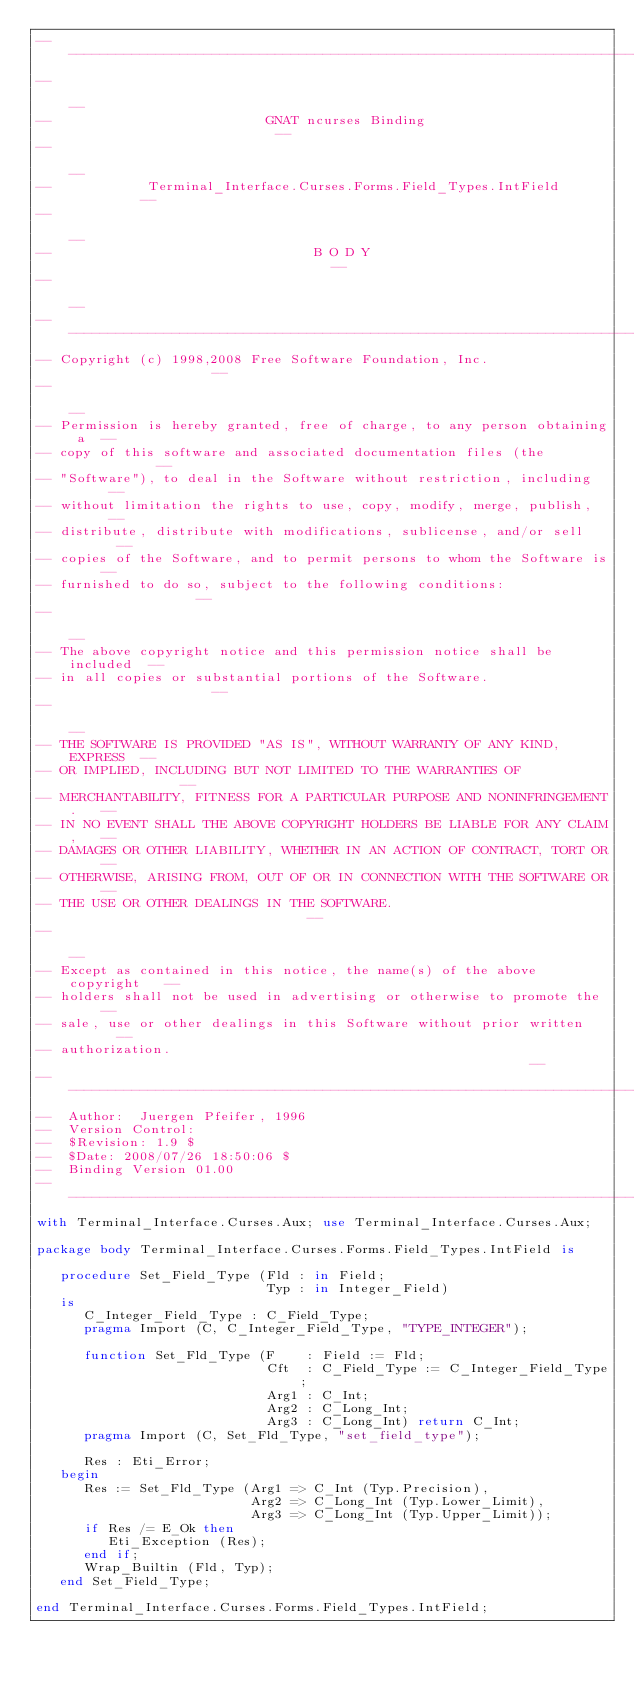<code> <loc_0><loc_0><loc_500><loc_500><_Ada_>------------------------------------------------------------------------------
--                                                                          --
--                           GNAT ncurses Binding                           --
--                                                                          --
--            Terminal_Interface.Curses.Forms.Field_Types.IntField          --
--                                                                          --
--                                 B O D Y                                  --
--                                                                          --
------------------------------------------------------------------------------
-- Copyright (c) 1998,2008 Free Software Foundation, Inc.                   --
--                                                                          --
-- Permission is hereby granted, free of charge, to any person obtaining a  --
-- copy of this software and associated documentation files (the            --
-- "Software"), to deal in the Software without restriction, including      --
-- without limitation the rights to use, copy, modify, merge, publish,      --
-- distribute, distribute with modifications, sublicense, and/or sell       --
-- copies of the Software, and to permit persons to whom the Software is    --
-- furnished to do so, subject to the following conditions:                 --
--                                                                          --
-- The above copyright notice and this permission notice shall be included  --
-- in all copies or substantial portions of the Software.                   --
--                                                                          --
-- THE SOFTWARE IS PROVIDED "AS IS", WITHOUT WARRANTY OF ANY KIND, EXPRESS  --
-- OR IMPLIED, INCLUDING BUT NOT LIMITED TO THE WARRANTIES OF               --
-- MERCHANTABILITY, FITNESS FOR A PARTICULAR PURPOSE AND NONINFRINGEMENT.   --
-- IN NO EVENT SHALL THE ABOVE COPYRIGHT HOLDERS BE LIABLE FOR ANY CLAIM,   --
-- DAMAGES OR OTHER LIABILITY, WHETHER IN AN ACTION OF CONTRACT, TORT OR    --
-- OTHERWISE, ARISING FROM, OUT OF OR IN CONNECTION WITH THE SOFTWARE OR    --
-- THE USE OR OTHER DEALINGS IN THE SOFTWARE.                               --
--                                                                          --
-- Except as contained in this notice, the name(s) of the above copyright   --
-- holders shall not be used in advertising or otherwise to promote the     --
-- sale, use or other dealings in this Software without prior written       --
-- authorization.                                                           --
------------------------------------------------------------------------------
--  Author:  Juergen Pfeifer, 1996
--  Version Control:
--  $Revision: 1.9 $
--  $Date: 2008/07/26 18:50:06 $
--  Binding Version 01.00
------------------------------------------------------------------------------
with Terminal_Interface.Curses.Aux; use Terminal_Interface.Curses.Aux;

package body Terminal_Interface.Curses.Forms.Field_Types.IntField is

   procedure Set_Field_Type (Fld : in Field;
                             Typ : in Integer_Field)
   is
      C_Integer_Field_Type : C_Field_Type;
      pragma Import (C, C_Integer_Field_Type, "TYPE_INTEGER");

      function Set_Fld_Type (F    : Field := Fld;
                             Cft  : C_Field_Type := C_Integer_Field_Type;
                             Arg1 : C_Int;
                             Arg2 : C_Long_Int;
                             Arg3 : C_Long_Int) return C_Int;
      pragma Import (C, Set_Fld_Type, "set_field_type");

      Res : Eti_Error;
   begin
      Res := Set_Fld_Type (Arg1 => C_Int (Typ.Precision),
                           Arg2 => C_Long_Int (Typ.Lower_Limit),
                           Arg3 => C_Long_Int (Typ.Upper_Limit));
      if Res /= E_Ok then
         Eti_Exception (Res);
      end if;
      Wrap_Builtin (Fld, Typ);
   end Set_Field_Type;

end Terminal_Interface.Curses.Forms.Field_Types.IntField;
</code> 